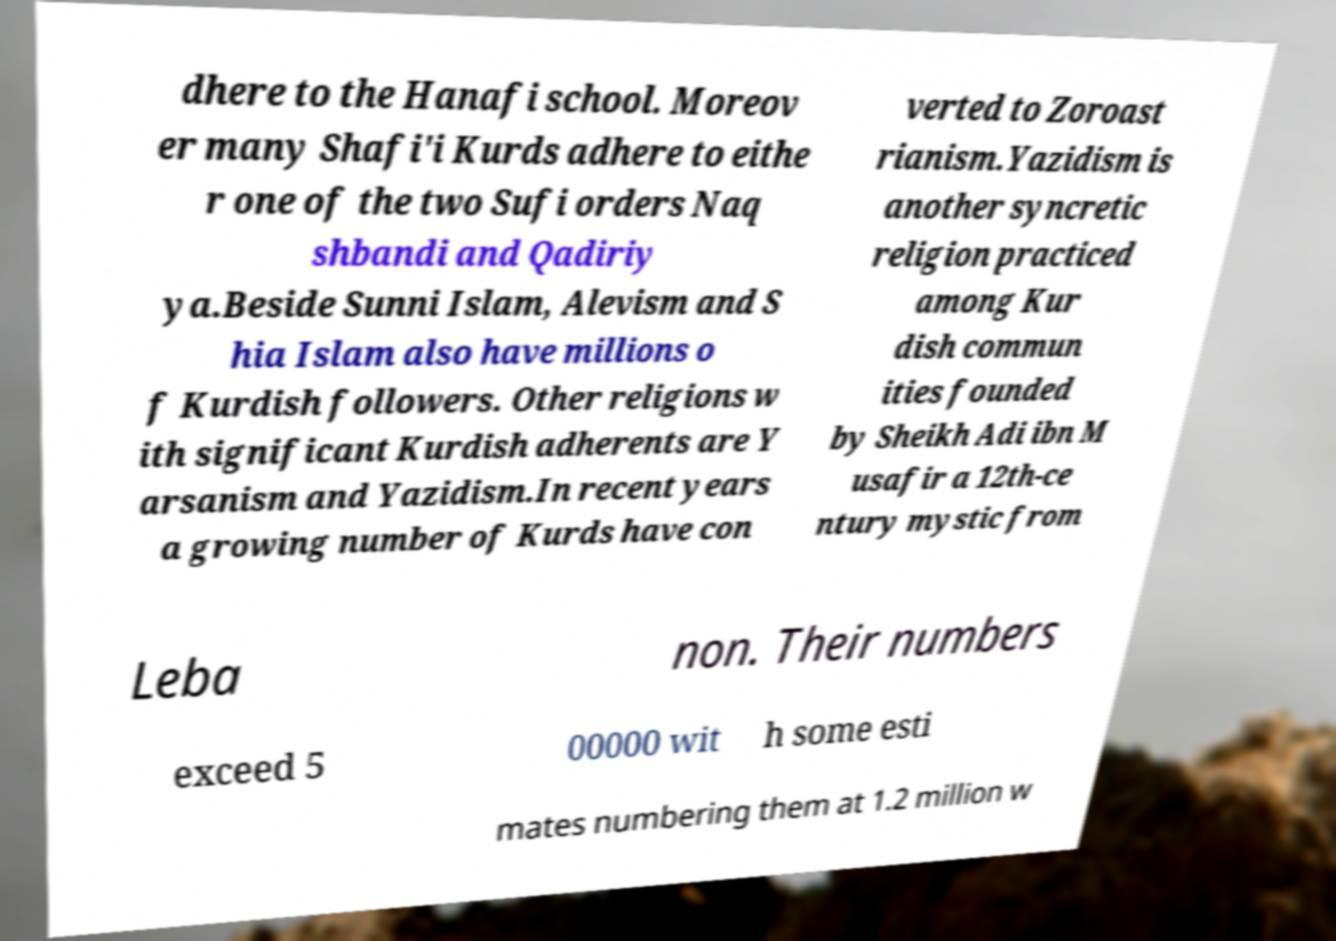I need the written content from this picture converted into text. Can you do that? dhere to the Hanafi school. Moreov er many Shafi'i Kurds adhere to eithe r one of the two Sufi orders Naq shbandi and Qadiriy ya.Beside Sunni Islam, Alevism and S hia Islam also have millions o f Kurdish followers. Other religions w ith significant Kurdish adherents are Y arsanism and Yazidism.In recent years a growing number of Kurds have con verted to Zoroast rianism.Yazidism is another syncretic religion practiced among Kur dish commun ities founded by Sheikh Adi ibn M usafir a 12th-ce ntury mystic from Leba non. Their numbers exceed 5 00000 wit h some esti mates numbering them at 1.2 million w 